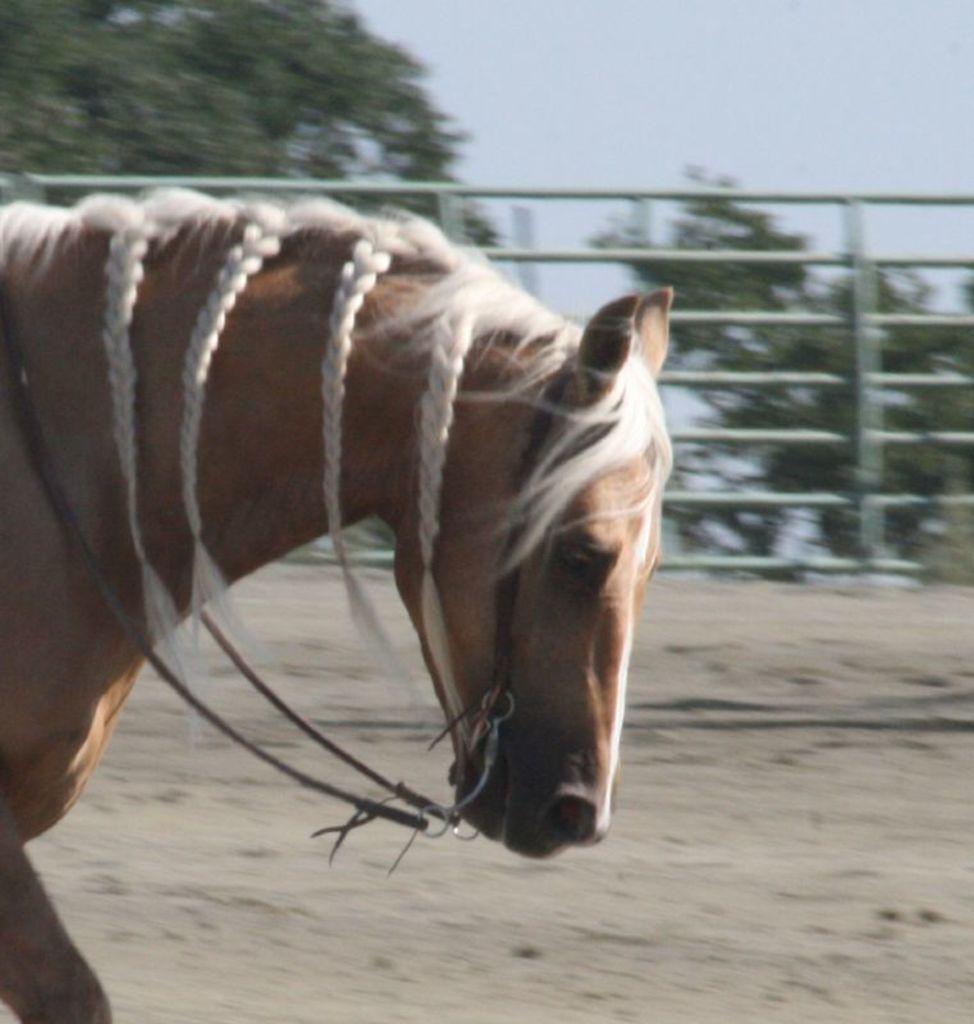Please provide a concise description of this image. In the image we can see a horse, brown and white in color. Here we can see the fence, and, trees and a sky. 